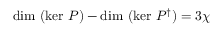Convert formula to latex. <formula><loc_0><loc_0><loc_500><loc_500>d i m ( k e r P ) - d i m ( k e r P ^ { \dag } ) = 3 \chi</formula> 